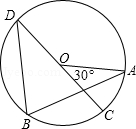How does the positioning of points A and D affect the measurement of angles within the circle? The positions of points A and D, specifically as endpoints of a diameter, are crucial in circular geometry. Their placement dictates the measurement of angles within the circle by establishing the critical angle subtended at the circle's center, which in turn influences the measurements of inscribed angles. For example, if angle AOD is a straight angle (180°), any inscribed angle opposite the arc AD will measure exactly 90°, demonstrating the direct impact of the positioning of these points on angle calculations. 